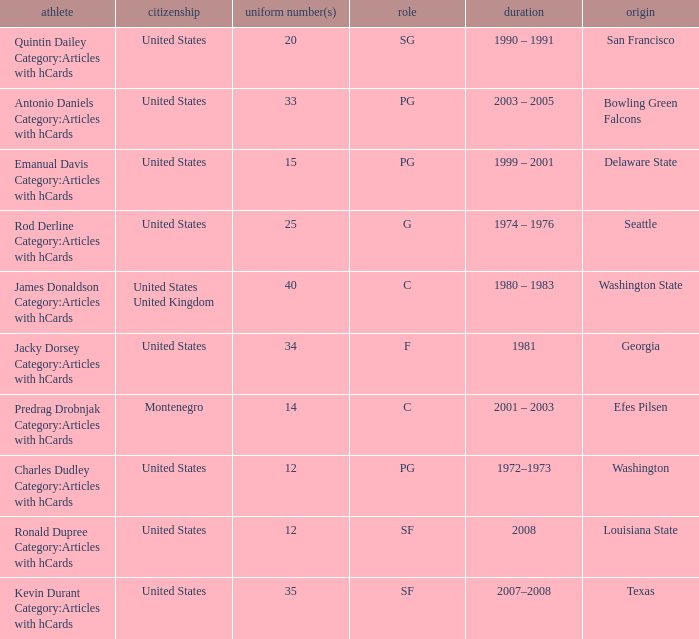What was the nationality of the players with a position of g? United States. 